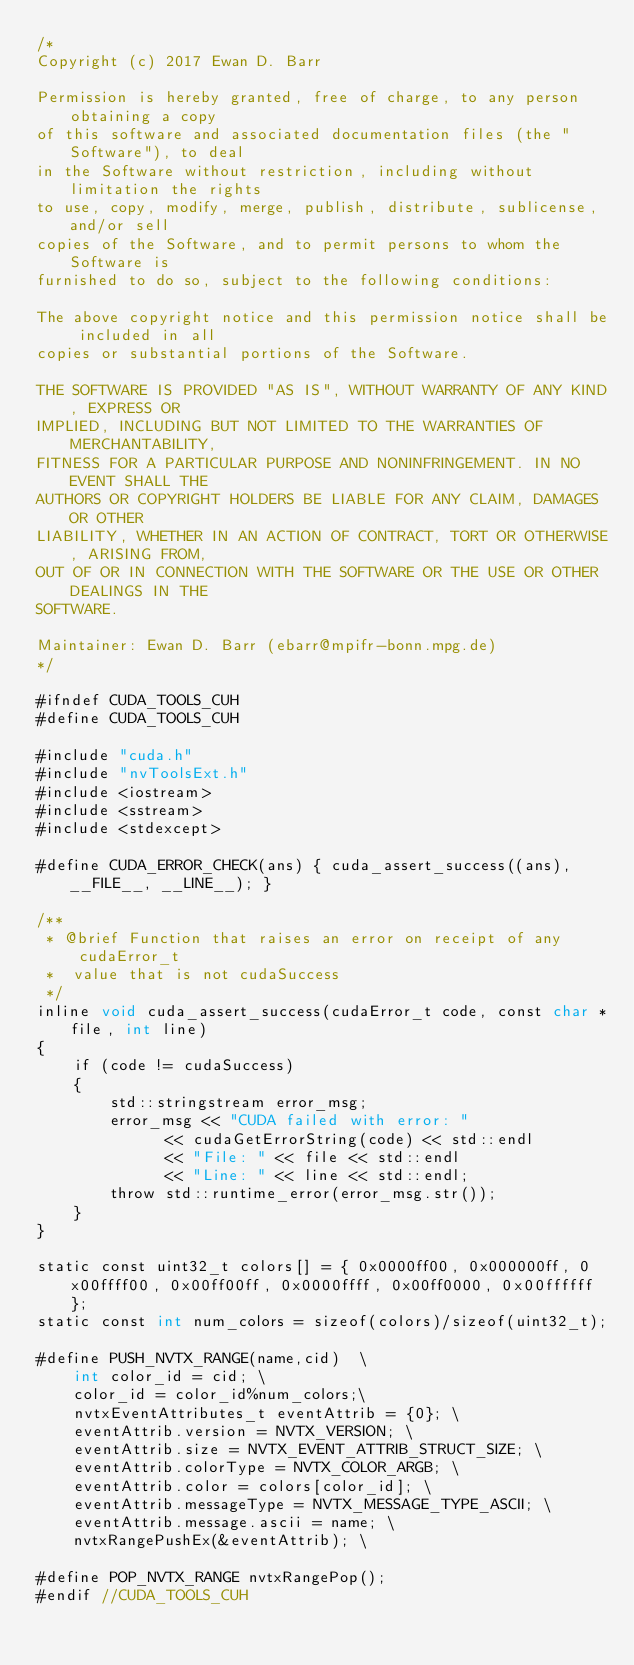Convert code to text. <code><loc_0><loc_0><loc_500><loc_500><_Cuda_>/*
Copyright (c) 2017 Ewan D. Barr

Permission is hereby granted, free of charge, to any person obtaining a copy
of this software and associated documentation files (the "Software"), to deal
in the Software without restriction, including without limitation the rights
to use, copy, modify, merge, publish, distribute, sublicense, and/or sell
copies of the Software, and to permit persons to whom the Software is
furnished to do so, subject to the following conditions:

The above copyright notice and this permission notice shall be included in all
copies or substantial portions of the Software.

THE SOFTWARE IS PROVIDED "AS IS", WITHOUT WARRANTY OF ANY KIND, EXPRESS OR
IMPLIED, INCLUDING BUT NOT LIMITED TO THE WARRANTIES OF MERCHANTABILITY,
FITNESS FOR A PARTICULAR PURPOSE AND NONINFRINGEMENT. IN NO EVENT SHALL THE
AUTHORS OR COPYRIGHT HOLDERS BE LIABLE FOR ANY CLAIM, DAMAGES OR OTHER
LIABILITY, WHETHER IN AN ACTION OF CONTRACT, TORT OR OTHERWISE, ARISING FROM,
OUT OF OR IN CONNECTION WITH THE SOFTWARE OR THE USE OR OTHER DEALINGS IN THE
SOFTWARE. 

Maintainer: Ewan D. Barr (ebarr@mpifr-bonn.mpg.de) 
*/

#ifndef CUDA_TOOLS_CUH
#define CUDA_TOOLS_CUH

#include "cuda.h"
#include "nvToolsExt.h"
#include <iostream>
#include <sstream>
#include <stdexcept>

#define CUDA_ERROR_CHECK(ans) { cuda_assert_success((ans), __FILE__, __LINE__); }

/**
 * @brief Function that raises an error on receipt of any cudaError_t
 *  value that is not cudaSuccess
 */
inline void cuda_assert_success(cudaError_t code, const char *file, int line)
{
    if (code != cudaSuccess)
    {
        std::stringstream error_msg;
        error_msg << "CUDA failed with error: "
              << cudaGetErrorString(code) << std::endl
              << "File: " << file << std::endl
              << "Line: " << line << std::endl;
        throw std::runtime_error(error_msg.str());
    }
}

static const uint32_t colors[] = { 0x0000ff00, 0x000000ff, 0x00ffff00, 0x00ff00ff, 0x0000ffff, 0x00ff0000, 0x00ffffff };
static const int num_colors = sizeof(colors)/sizeof(uint32_t);

#define PUSH_NVTX_RANGE(name,cid)  \
    int color_id = cid; \
    color_id = color_id%num_colors;\
    nvtxEventAttributes_t eventAttrib = {0}; \
    eventAttrib.version = NVTX_VERSION; \
    eventAttrib.size = NVTX_EVENT_ATTRIB_STRUCT_SIZE; \
    eventAttrib.colorType = NVTX_COLOR_ARGB; \
    eventAttrib.color = colors[color_id]; \
    eventAttrib.messageType = NVTX_MESSAGE_TYPE_ASCII; \
    eventAttrib.message.ascii = name; \
    nvtxRangePushEx(&eventAttrib); \

#define POP_NVTX_RANGE nvtxRangePop();
#endif //CUDA_TOOLS_CUH</code> 